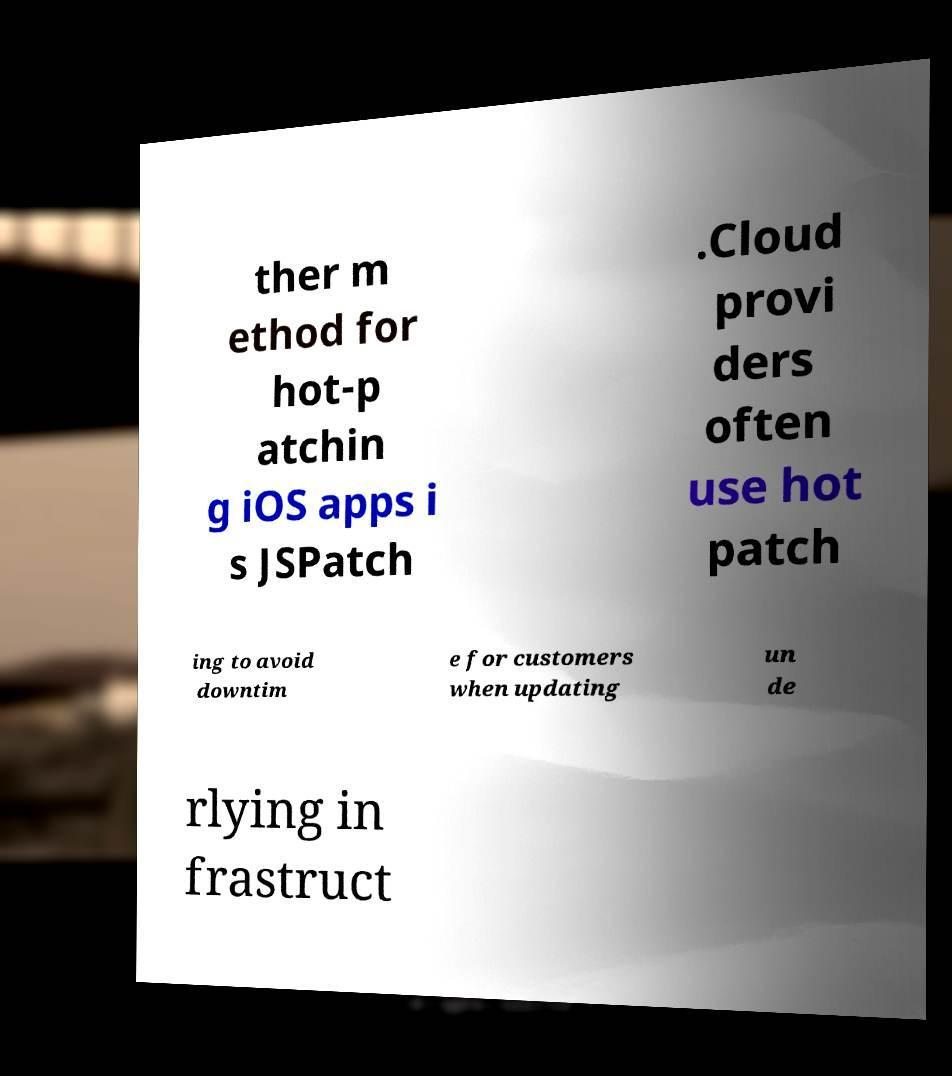I need the written content from this picture converted into text. Can you do that? ther m ethod for hot-p atchin g iOS apps i s JSPatch .Cloud provi ders often use hot patch ing to avoid downtim e for customers when updating un de rlying in frastruct 